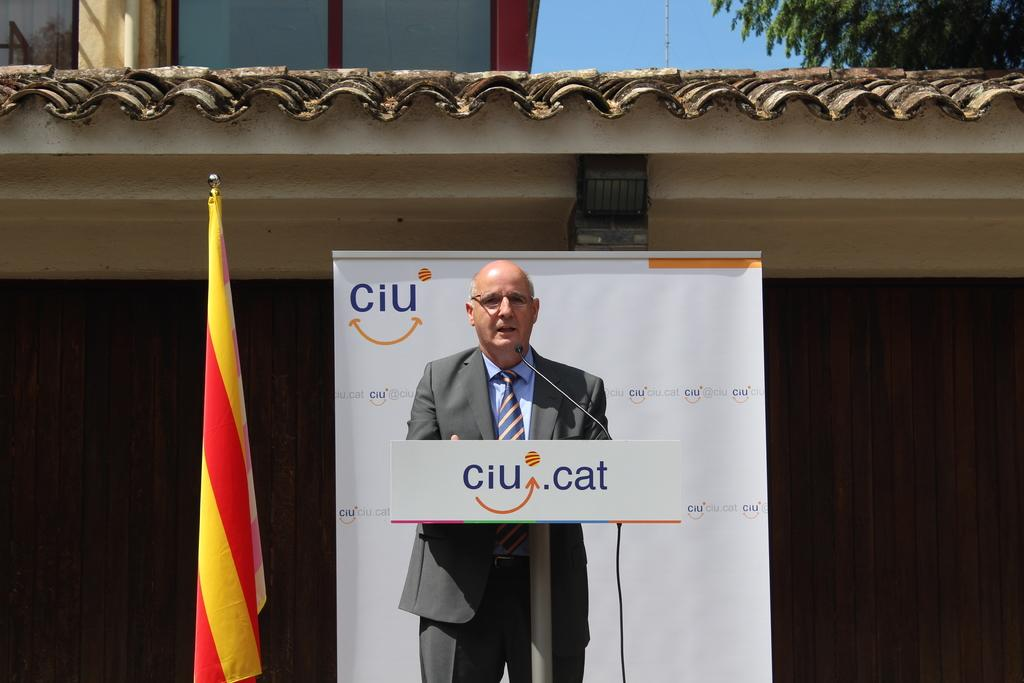What is the person in the image doing? The person is standing and speaking into a microphone. What can be seen in the image besides the person? There is a flag, a building, and a tree at the top right side of the image. How many alleys are visible in the image? There are no alleys present in the image. What type of apparatus is being used by the person in the image? The person is speaking into a microphone, which is not an apparatus. 